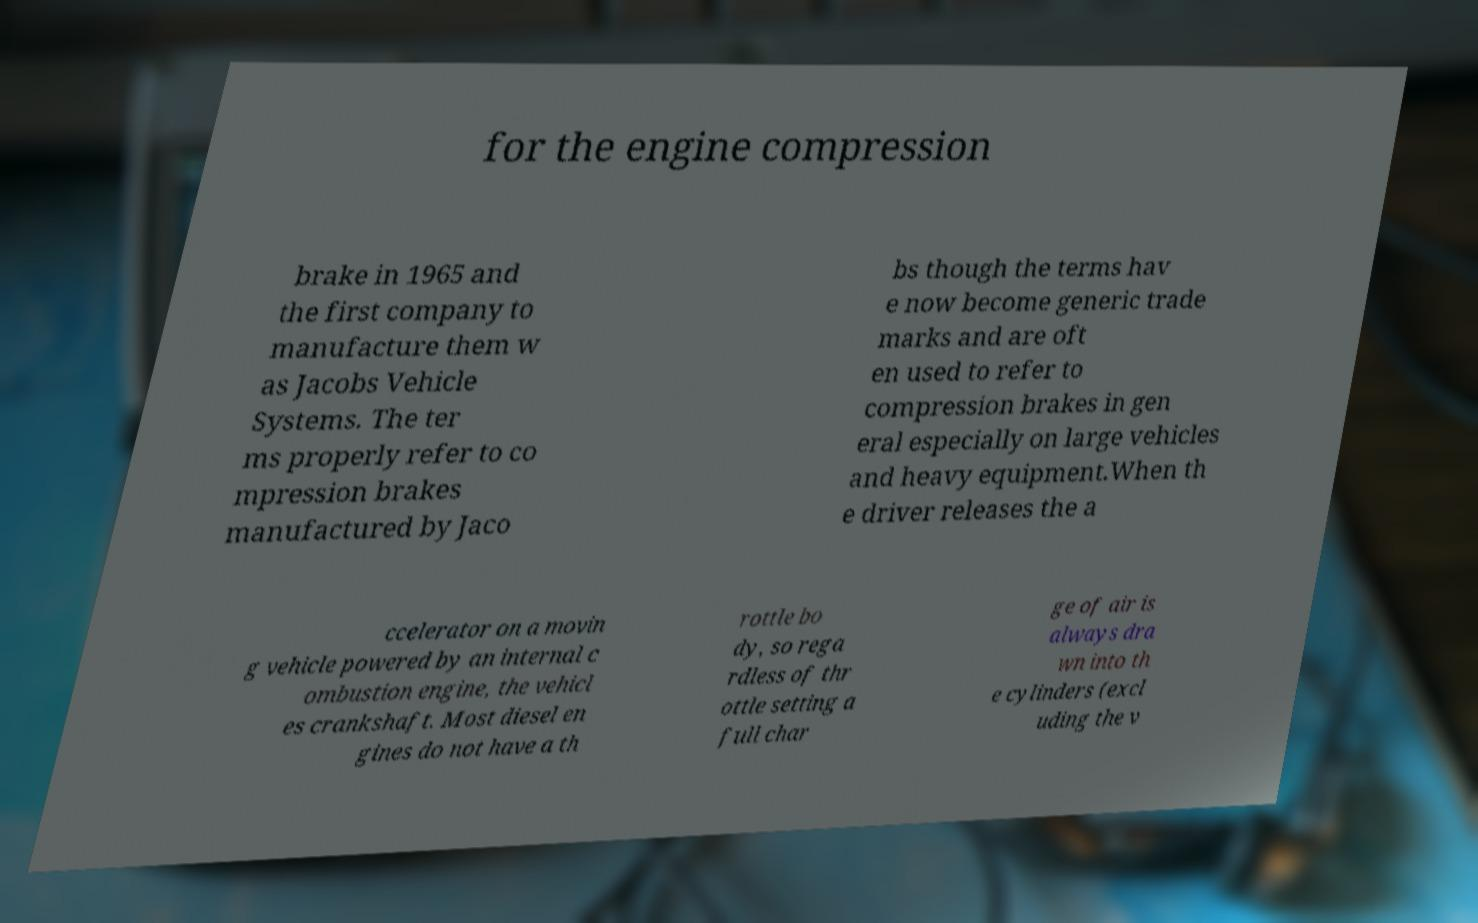Please identify and transcribe the text found in this image. for the engine compression brake in 1965 and the first company to manufacture them w as Jacobs Vehicle Systems. The ter ms properly refer to co mpression brakes manufactured by Jaco bs though the terms hav e now become generic trade marks and are oft en used to refer to compression brakes in gen eral especially on large vehicles and heavy equipment.When th e driver releases the a ccelerator on a movin g vehicle powered by an internal c ombustion engine, the vehicl es crankshaft. Most diesel en gines do not have a th rottle bo dy, so rega rdless of thr ottle setting a full char ge of air is always dra wn into th e cylinders (excl uding the v 